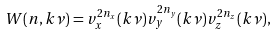<formula> <loc_0><loc_0><loc_500><loc_500>W ( { n } , { k } \nu ) = v _ { x } ^ { 2 n _ { x } } ( { k } \nu ) v _ { y } ^ { 2 n _ { y } } ( { k } \nu ) v _ { z } ^ { 2 n _ { z } } ( { k } \nu ) ,</formula> 